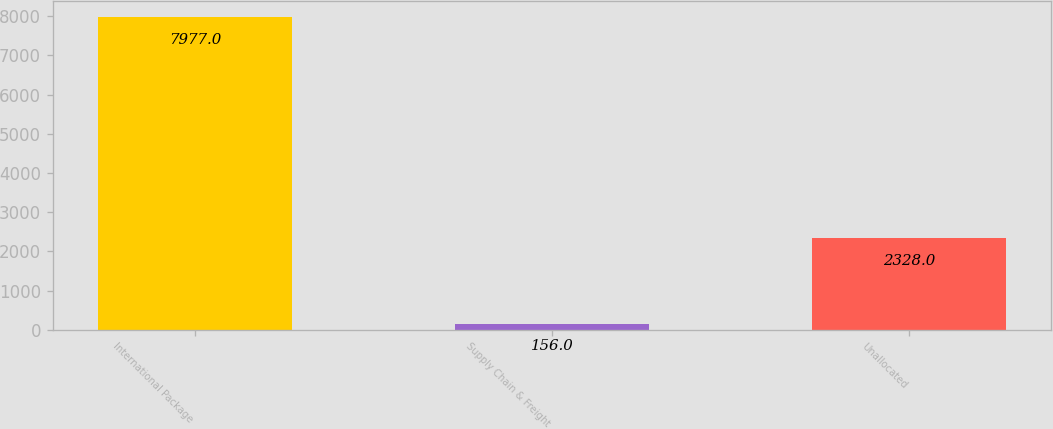Convert chart. <chart><loc_0><loc_0><loc_500><loc_500><bar_chart><fcel>International Package<fcel>Supply Chain & Freight<fcel>Unallocated<nl><fcel>7977<fcel>156<fcel>2328<nl></chart> 